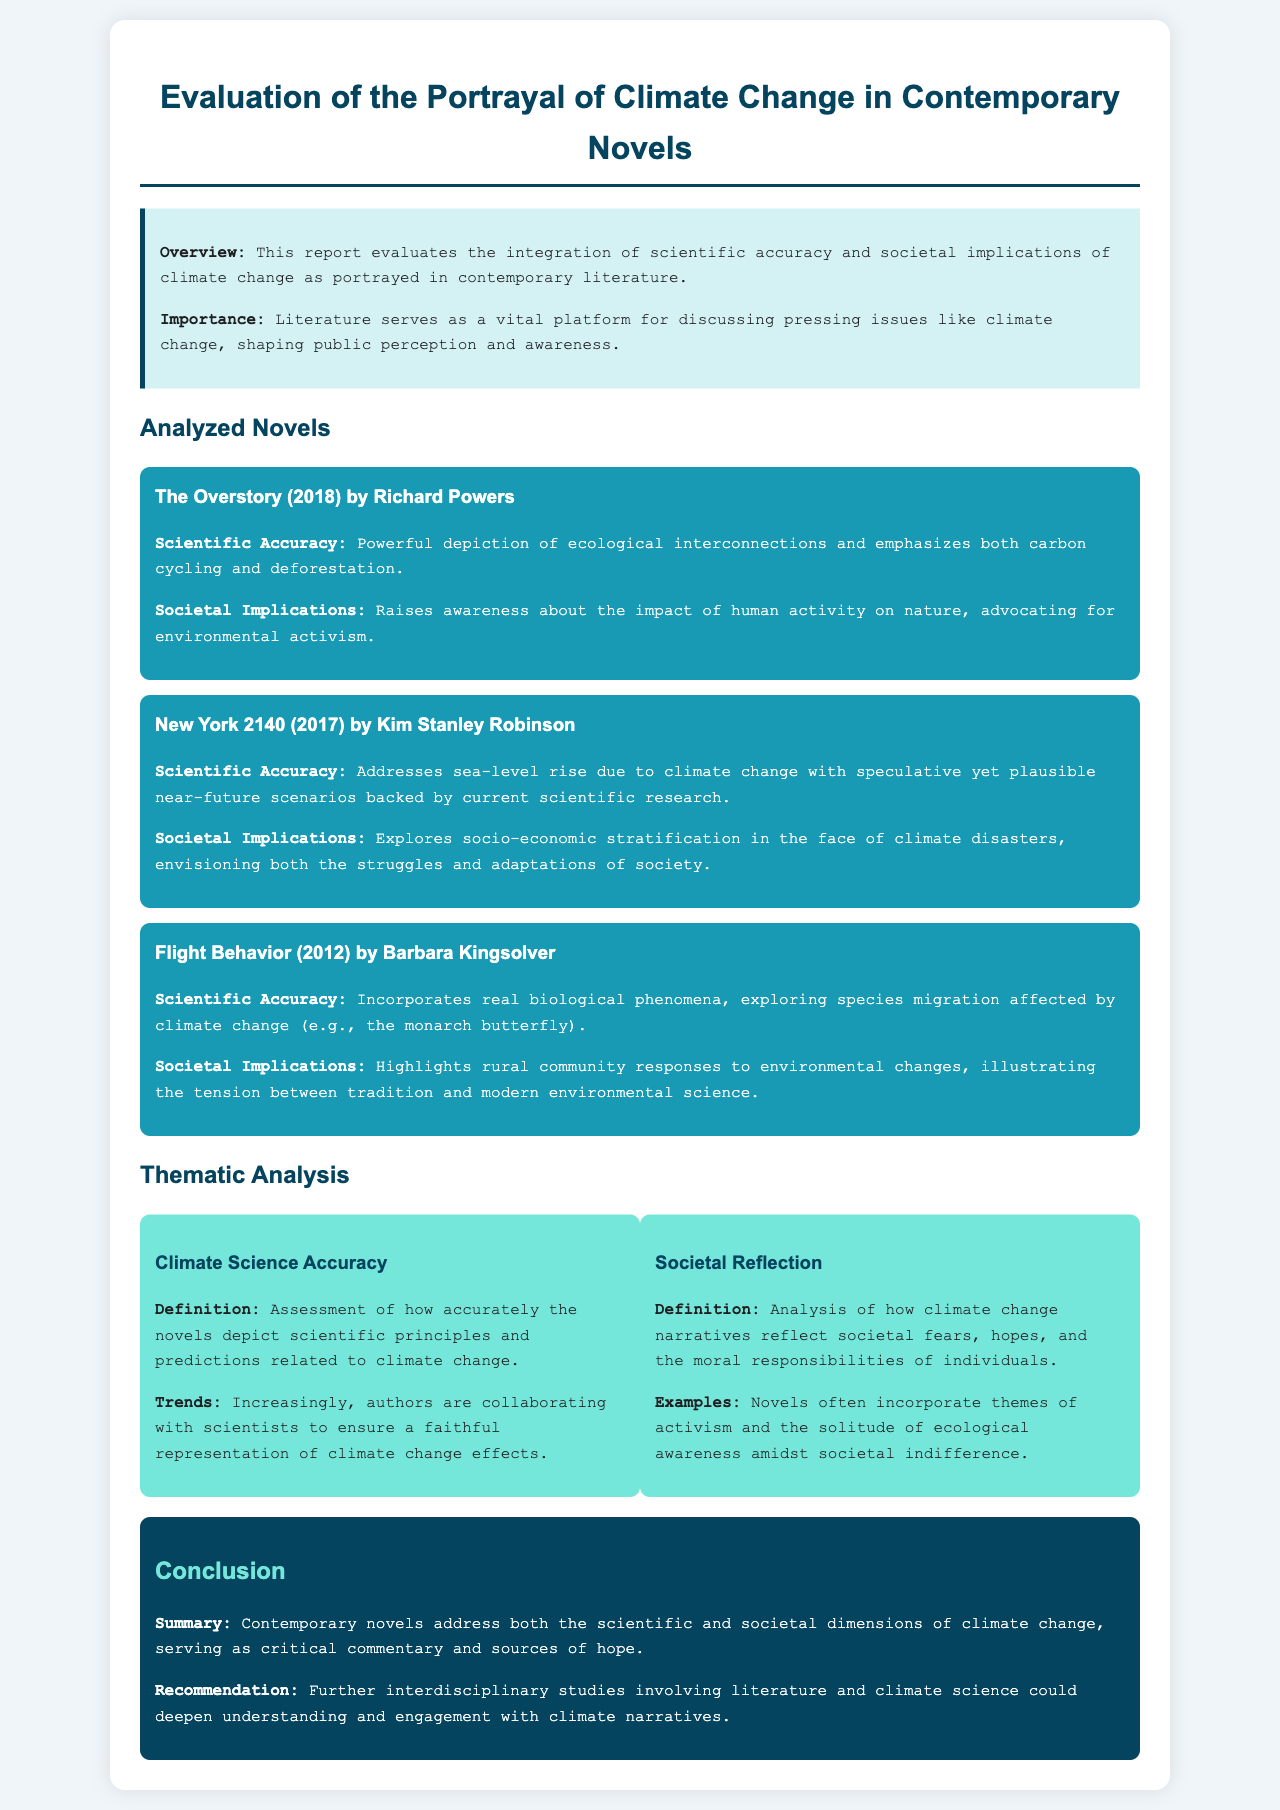What is the title of the report? The title of the report is stated prominently at the top of the document.
Answer: Evaluation of the Portrayal of Climate Change in Contemporary Novels Who is the author of "The Overstory"? The document mentions the author’s name next to the title of the novel.
Answer: Richard Powers What year was "New York 2140" published? The publication year for "New York 2140" is indicated alongside the novel's title.
Answer: 2017 What theme addresses climate science accuracy? The thematic analysis section categorizes the themes related to climate change narratives.
Answer: Climate Science Accuracy What is one recommendation given in the conclusion? The conclusion section provides suggestions for future research directions based on the findings of the report.
Answer: Further interdisciplinary studies involving literature and climate science 